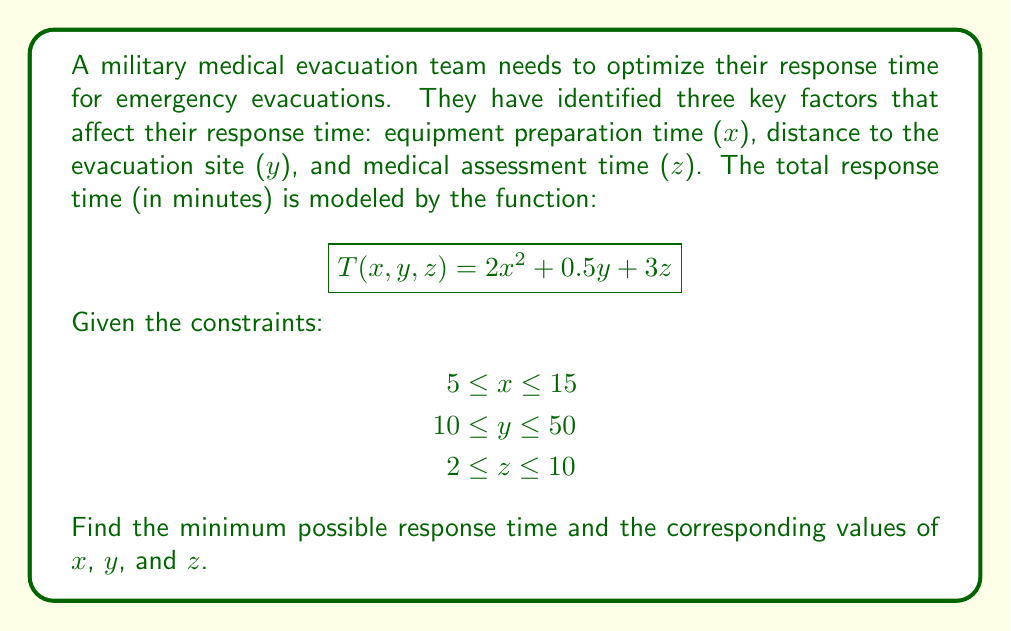Can you answer this question? To minimize the response time, we need to find the values of $x$, $y$, and $z$ that minimize the function $T(x, y, z)$ subject to the given constraints. Let's approach this step-by-step:

1. Analyze the function:
   $T(x, y, z) = 2x^2 + 0.5y + 3z$
   
   - The term with $x$ is quadratic and positive, so $T$ increases as $x$ increases.
   - The terms with $y$ and $z$ are linear and positive, so $T$ increases as $y$ and $z$ increase.

2. Given the nature of the function, the minimum will occur at the lowest possible values of $x$, $y$, and $z$ within the constraints.

3. For $x$:
   The minimum value within the constraint is $x = 5$.

4. For $y$:
   The minimum value within the constraint is $y = 10$.

5. For $z$:
   The minimum value within the constraint is $z = 2$.

6. Calculate the minimum response time:
   $$T_{min} = T(5, 10, 2)$$
   $$T_{min} = 2(5^2) + 0.5(10) + 3(2)$$
   $$T_{min} = 50 + 5 + 6$$
   $$T_{min} = 61$$

Therefore, the minimum response time is 61 minutes, achieved when:
- Equipment preparation time (x) is 5 minutes
- Distance to evacuation site (y) is 10 units (e.g., kilometers)
- Medical assessment time (z) is 2 minutes
Answer: Minimum response time: 61 minutes
Optimal values: $x = 5$, $y = 10$, $z = 2$ 